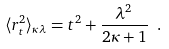Convert formula to latex. <formula><loc_0><loc_0><loc_500><loc_500>\langle { r } _ { t } ^ { 2 } \rangle _ { \kappa \lambda } = t ^ { 2 } + \frac { \lambda ^ { 2 } } { 2 \kappa + 1 } \ .</formula> 